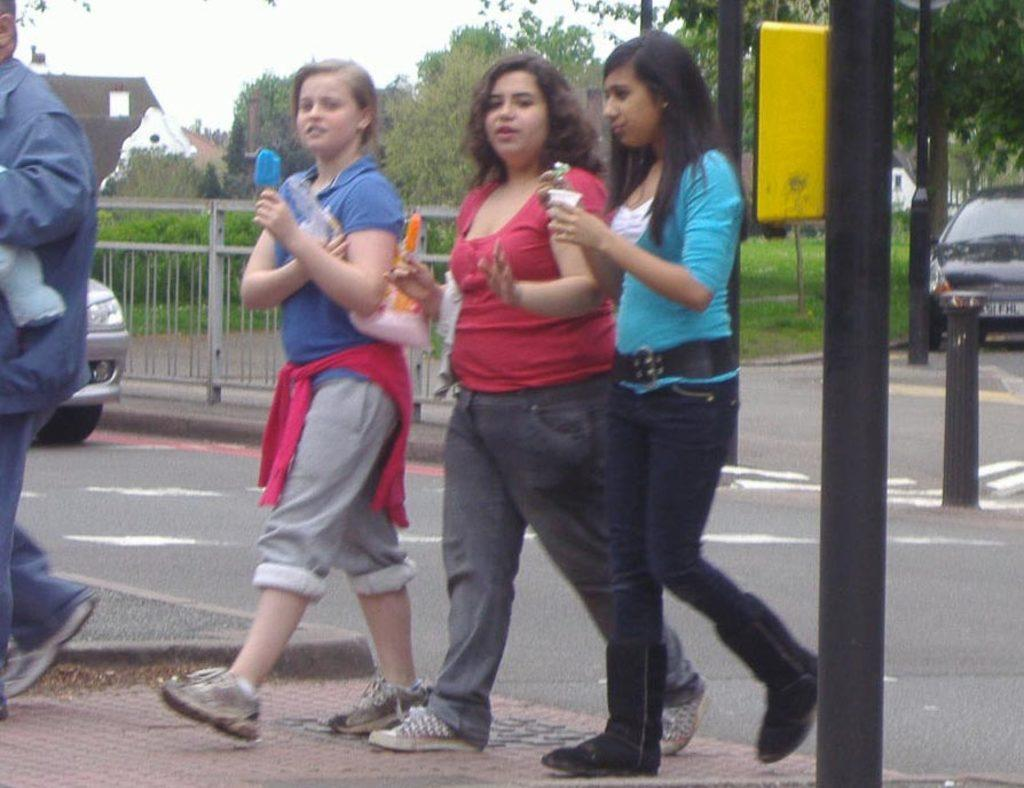How many women are in the image? There are three women in the image. What are the women doing in the image? The women are walking. What can be seen in the background of the image? There are vehicles moving in the background of the image. What type of vegetation is present in the image? There are plants and trees in the image. Is there a spy hiding among the trees in the image? There is no indication of a spy or any hidden figure in the image; it only shows three women walking and the presence of plants and trees. 